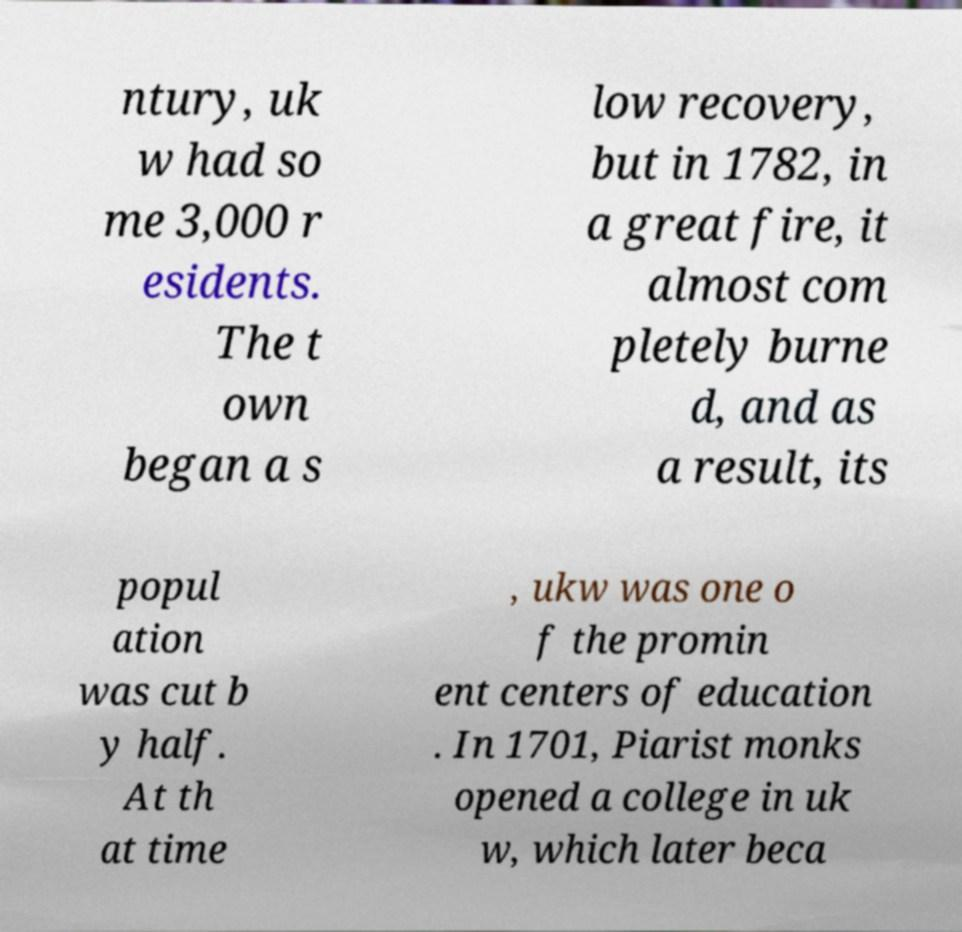Could you assist in decoding the text presented in this image and type it out clearly? ntury, uk w had so me 3,000 r esidents. The t own began a s low recovery, but in 1782, in a great fire, it almost com pletely burne d, and as a result, its popul ation was cut b y half. At th at time , ukw was one o f the promin ent centers of education . In 1701, Piarist monks opened a college in uk w, which later beca 